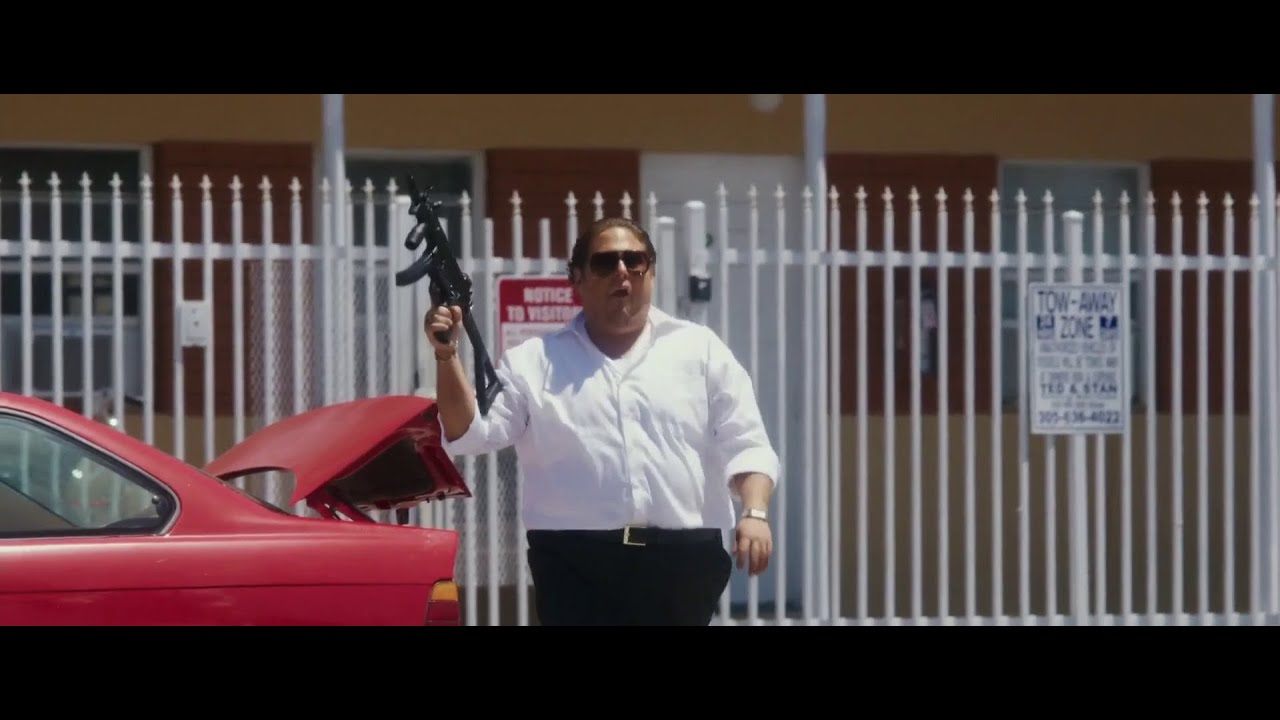Describe how the colors red and white are used in this scene. In this scene, the colors red and white play significant roles in enhancing the visual impact. The bright red of the car adds vibrancy and draws attention immediately, contrasting sharply with the predominant white from the man's shirt and the fence. This color scheme intensifies the dramatic nature of the scene, implying action and caution. 